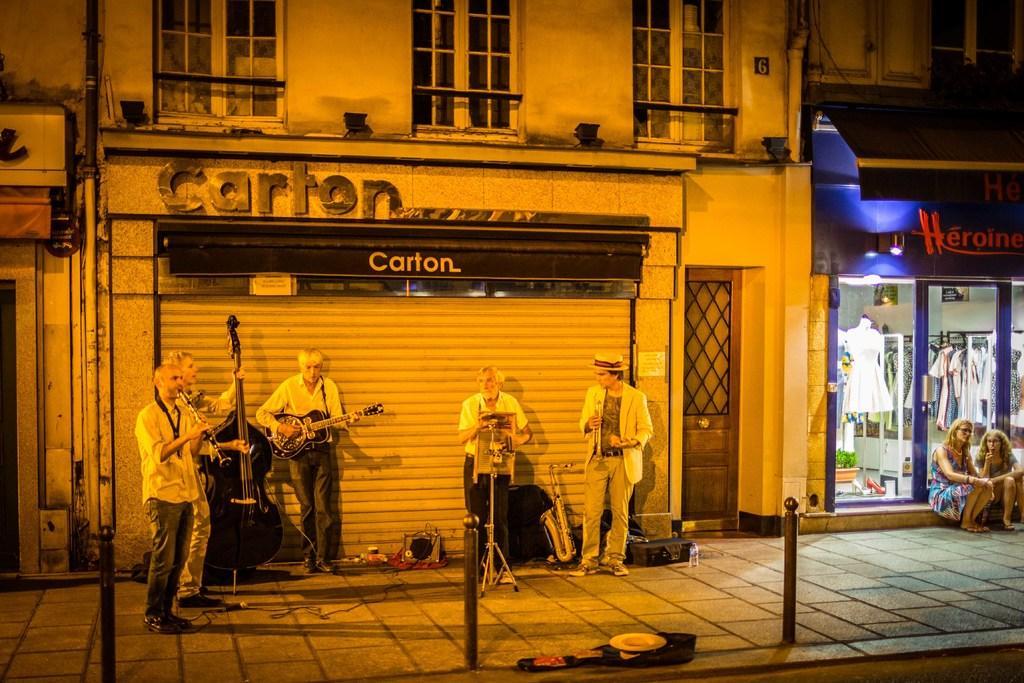In one or two sentences, can you explain what this image depicts? There are five men standing on the ground performing by playing musical instruments and we can see poles,hat and some other items on the ground. In the background there are buildings,windows,pipes,shutter and glass doors and two girls sitting at the glass door. Through the glass we can see dresses and frames on the wall. 